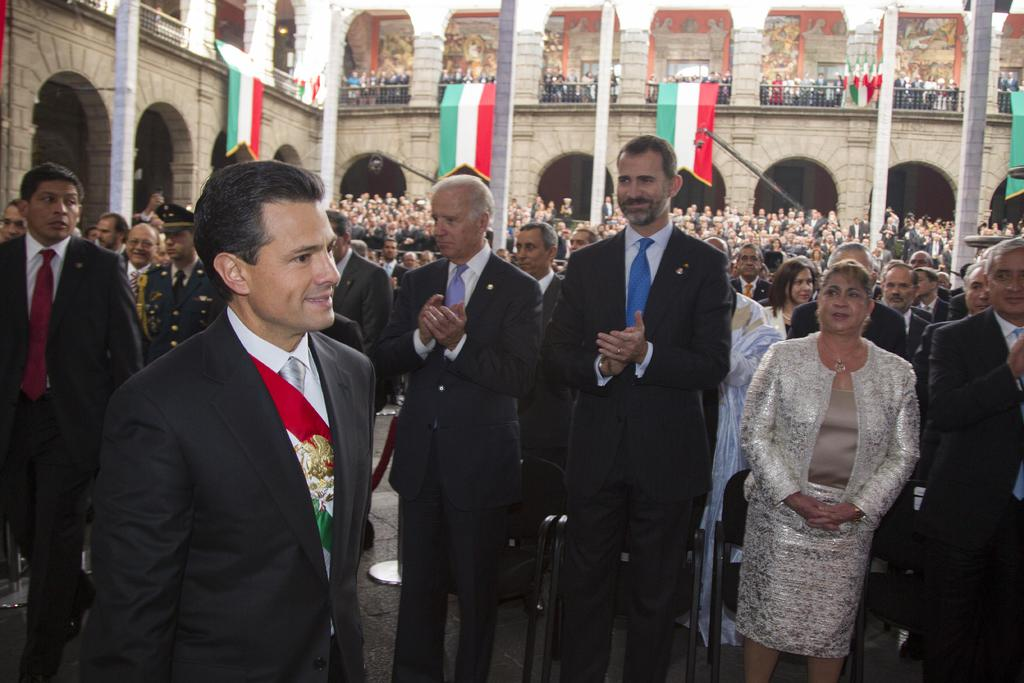How many people are in the image? There is a group of people in the image. What are the people wearing? The people are wearing different color dresses. What can be seen in the image besides the people? There are flags, railing, a building, and pillars in the image. What type of guitar is being played by the cat in the image? There is no cat or guitar present in the image. 